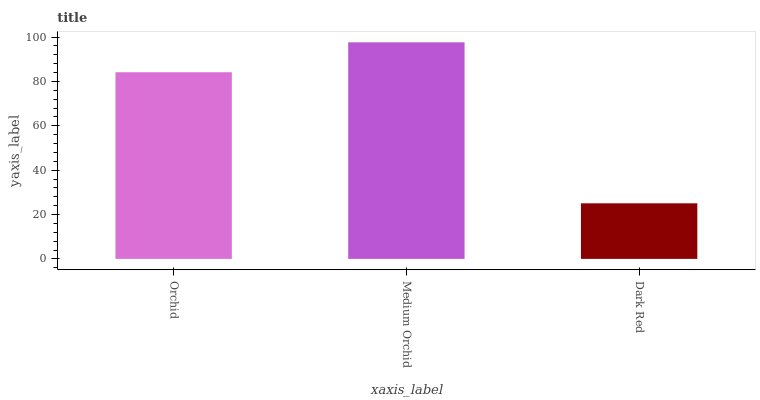Is Dark Red the minimum?
Answer yes or no. Yes. Is Medium Orchid the maximum?
Answer yes or no. Yes. Is Medium Orchid the minimum?
Answer yes or no. No. Is Dark Red the maximum?
Answer yes or no. No. Is Medium Orchid greater than Dark Red?
Answer yes or no. Yes. Is Dark Red less than Medium Orchid?
Answer yes or no. Yes. Is Dark Red greater than Medium Orchid?
Answer yes or no. No. Is Medium Orchid less than Dark Red?
Answer yes or no. No. Is Orchid the high median?
Answer yes or no. Yes. Is Orchid the low median?
Answer yes or no. Yes. Is Medium Orchid the high median?
Answer yes or no. No. Is Dark Red the low median?
Answer yes or no. No. 